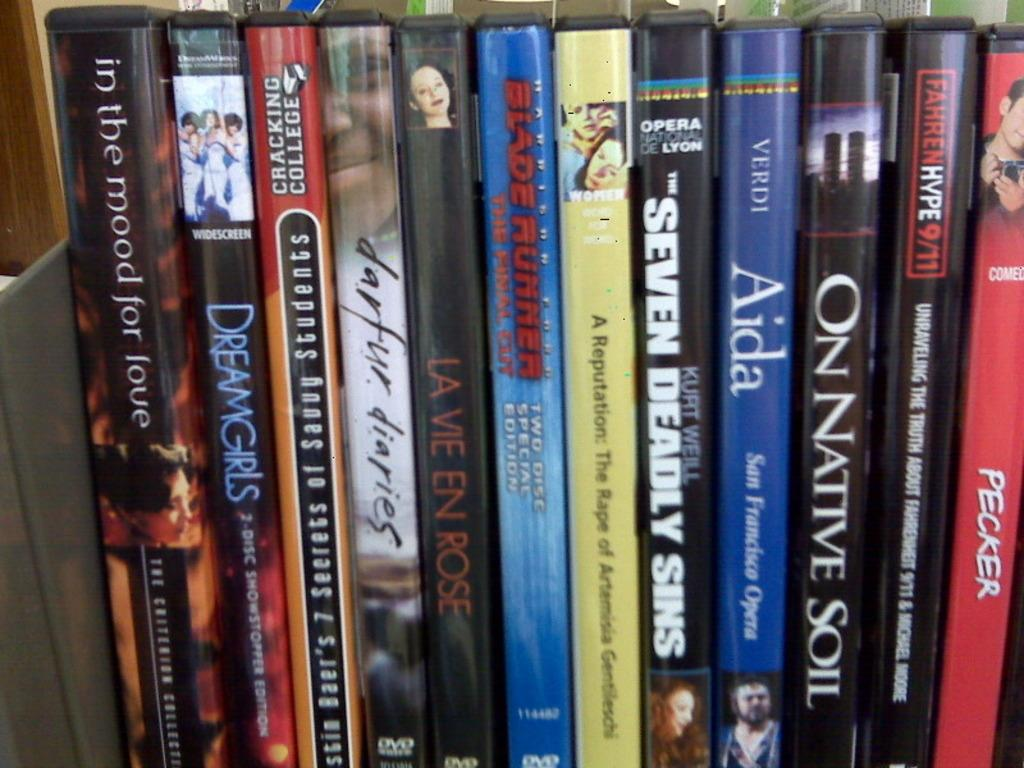<image>
Offer a succinct explanation of the picture presented. A copy of On Native Soil sits next to Aida on the shelf. 